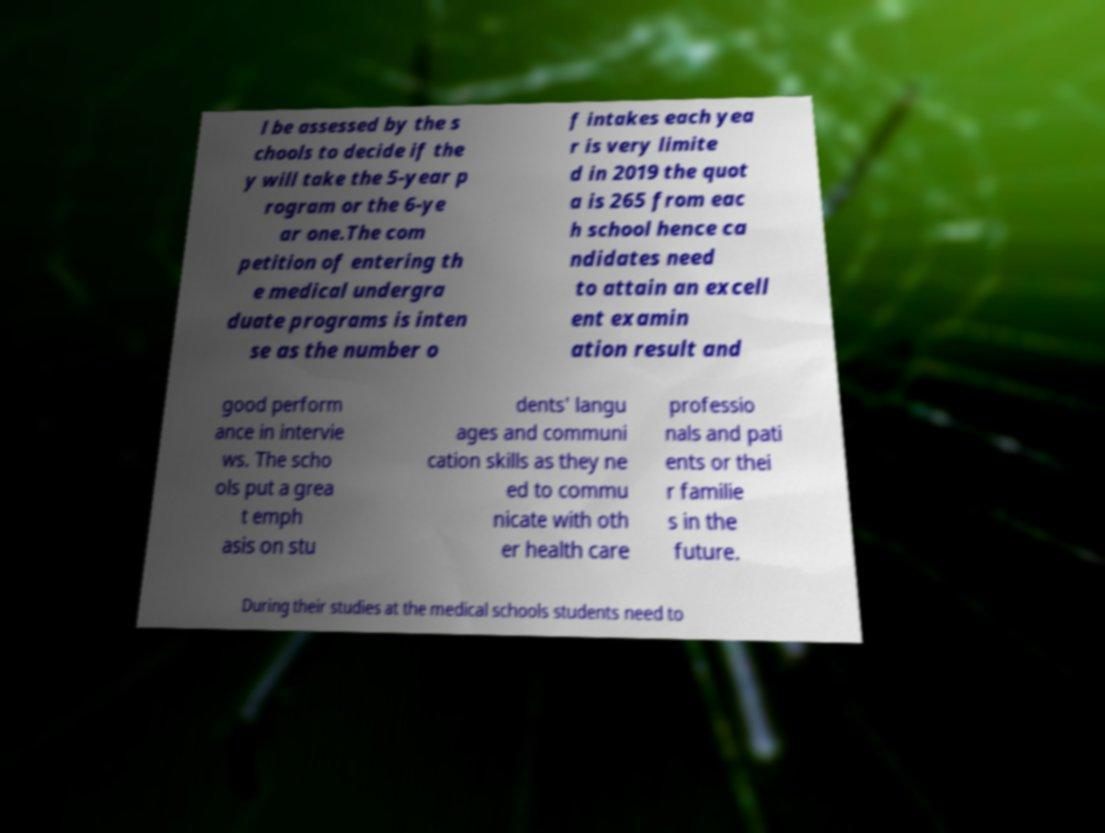Could you extract and type out the text from this image? l be assessed by the s chools to decide if the y will take the 5-year p rogram or the 6-ye ar one.The com petition of entering th e medical undergra duate programs is inten se as the number o f intakes each yea r is very limite d in 2019 the quot a is 265 from eac h school hence ca ndidates need to attain an excell ent examin ation result and good perform ance in intervie ws. The scho ols put a grea t emph asis on stu dents' langu ages and communi cation skills as they ne ed to commu nicate with oth er health care professio nals and pati ents or thei r familie s in the future. During their studies at the medical schools students need to 